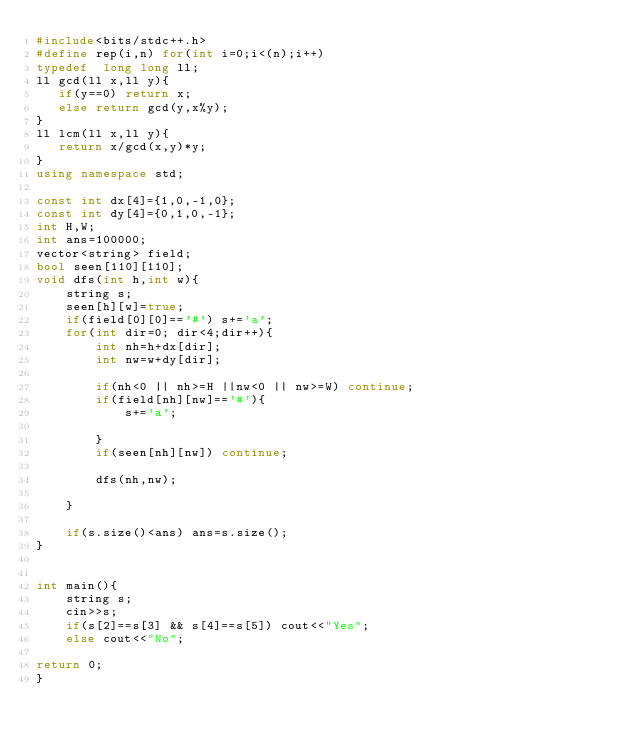Convert code to text. <code><loc_0><loc_0><loc_500><loc_500><_C++_>#include<bits/stdc++.h>
#define rep(i,n) for(int i=0;i<(n);i++)
typedef  long long ll;
ll gcd(ll x,ll y){
   if(y==0) return x;
   else return gcd(y,x%y);
}
ll lcm(ll x,ll y){
   return x/gcd(x,y)*y;
}
using namespace std;

const int dx[4]={1,0,-1,0};
const int dy[4]={0,1,0,-1};
int H,W;
int ans=100000;
vector<string> field;
bool seen[110][110];
void dfs(int h,int w){
    string s;
    seen[h][w]=true;
    if(field[0][0]=='#') s+='a';
    for(int dir=0; dir<4;dir++){
        int nh=h+dx[dir];
        int nw=w+dy[dir];

        if(nh<0 || nh>=H ||nw<0 || nw>=W) continue;
        if(field[nh][nw]=='#'){
            s+='a';
           
        }
        if(seen[nh][nw]) continue;

        dfs(nh,nw);
       
    } 
    
    if(s.size()<ans) ans=s.size(); 
}


int main(){
    string s;
    cin>>s;
    if(s[2]==s[3] && s[4]==s[5]) cout<<"Yes";
    else cout<<"No";

return 0;
}
</code> 